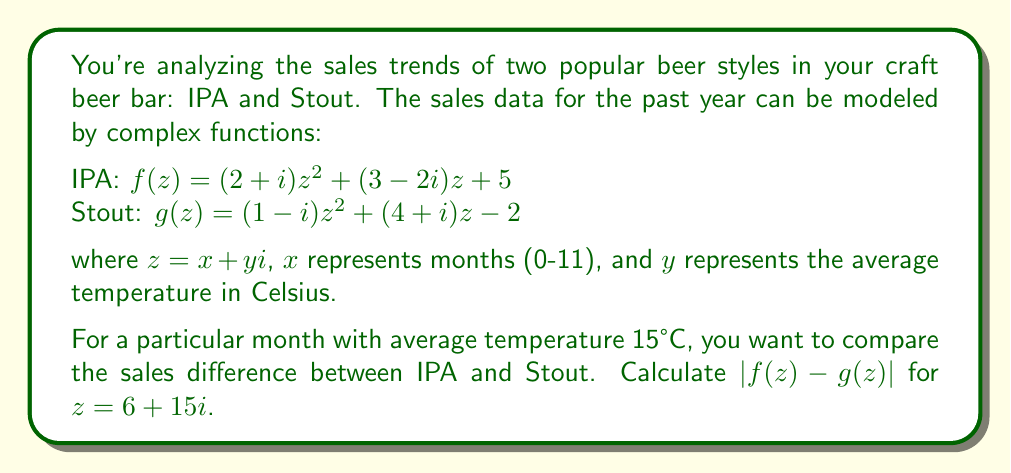Could you help me with this problem? Let's approach this step-by-step:

1) We need to calculate $f(z)$ and $g(z)$ for $z = 6 + 15i$, then find their difference and its magnitude.

2) For $f(z) = (2+i)z^2 + (3-2i)z + 5$:
   $f(6+15i) = (2+i)(6+15i)^2 + (3-2i)(6+15i) + 5$
   
   $(6+15i)^2 = 36 - 225 + 180i = -189 + 180i$
   
   $f(6+15i) = (2+i)(-189+180i) + (3-2i)(6+15i) + 5$
              $= (-378-189+360i+180i) + (18+45i-12i-30) + 5$
              $= (-567+540i) + (-12+33i) + 5$
              $= -574 + 573i$

3) For $g(z) = (1-i)z^2 + (4+i)z - 2$:
   $g(6+15i) = (1-i)(6+15i)^2 + (4+i)(6+15i) - 2$
   
   $g(6+15i) = (1-i)(-189+180i) + (4+i)(6+15i) - 2$
              $= (-189+180i+189i-180i^2) + (24+60i+6i+15i^2) - 2$
              $= (-189+369i+180) + (24+66i-15) - 2$
              $= -2 + 435i$

4) Now, let's calculate $f(z) - g(z)$:
   $(-574+573i) - (-2+435i) = -572 + 138i$

5) Finally, we need to find the magnitude of this complex number:
   $|f(z) - g(z)| = |-572 + 138i| = \sqrt{(-572)^2 + 138^2} = \sqrt{327184 + 19044} = \sqrt{346228} \approx 588.41$
Answer: $588.41$ 